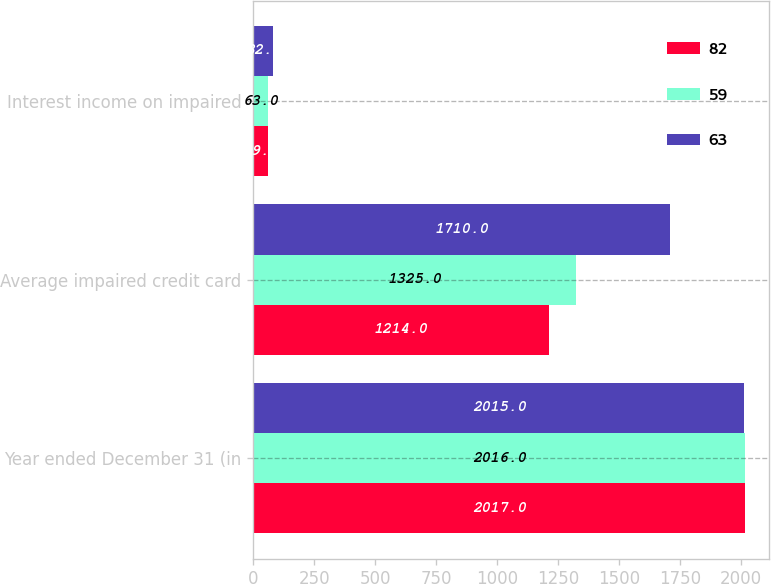Convert chart. <chart><loc_0><loc_0><loc_500><loc_500><stacked_bar_chart><ecel><fcel>Year ended December 31 (in<fcel>Average impaired credit card<fcel>Interest income on impaired<nl><fcel>82<fcel>2017<fcel>1214<fcel>59<nl><fcel>59<fcel>2016<fcel>1325<fcel>63<nl><fcel>63<fcel>2015<fcel>1710<fcel>82<nl></chart> 